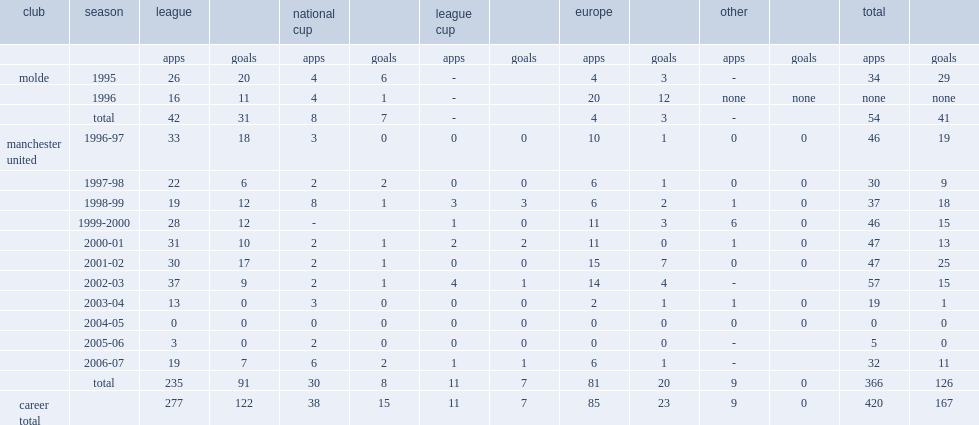How many goals did ole gunnar solskjær score for united totally? 126.0. 